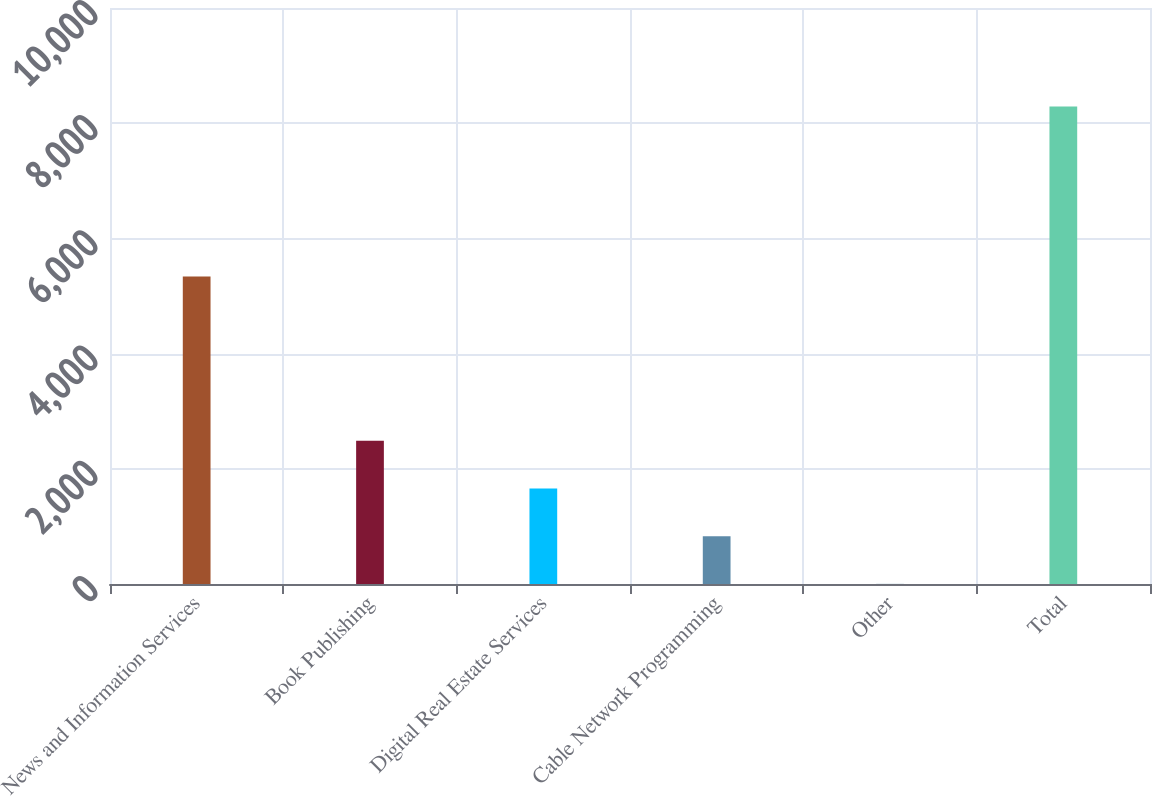<chart> <loc_0><loc_0><loc_500><loc_500><bar_chart><fcel>News and Information Services<fcel>Book Publishing<fcel>Digital Real Estate Services<fcel>Cable Network Programming<fcel>Other<fcel>Total<nl><fcel>5338<fcel>2489<fcel>1660<fcel>831<fcel>2<fcel>8292<nl></chart> 